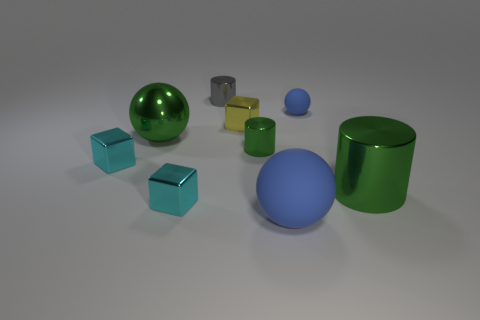Subtract all big balls. How many balls are left? 1 Subtract 1 blocks. How many blocks are left? 2 Add 1 yellow objects. How many objects exist? 10 Subtract all purple cylinders. Subtract all purple spheres. How many cylinders are left? 3 Subtract all spheres. How many objects are left? 6 Subtract all small blue matte objects. Subtract all small blue matte objects. How many objects are left? 7 Add 9 big blue things. How many big blue things are left? 10 Add 2 matte balls. How many matte balls exist? 4 Subtract 0 yellow cylinders. How many objects are left? 9 